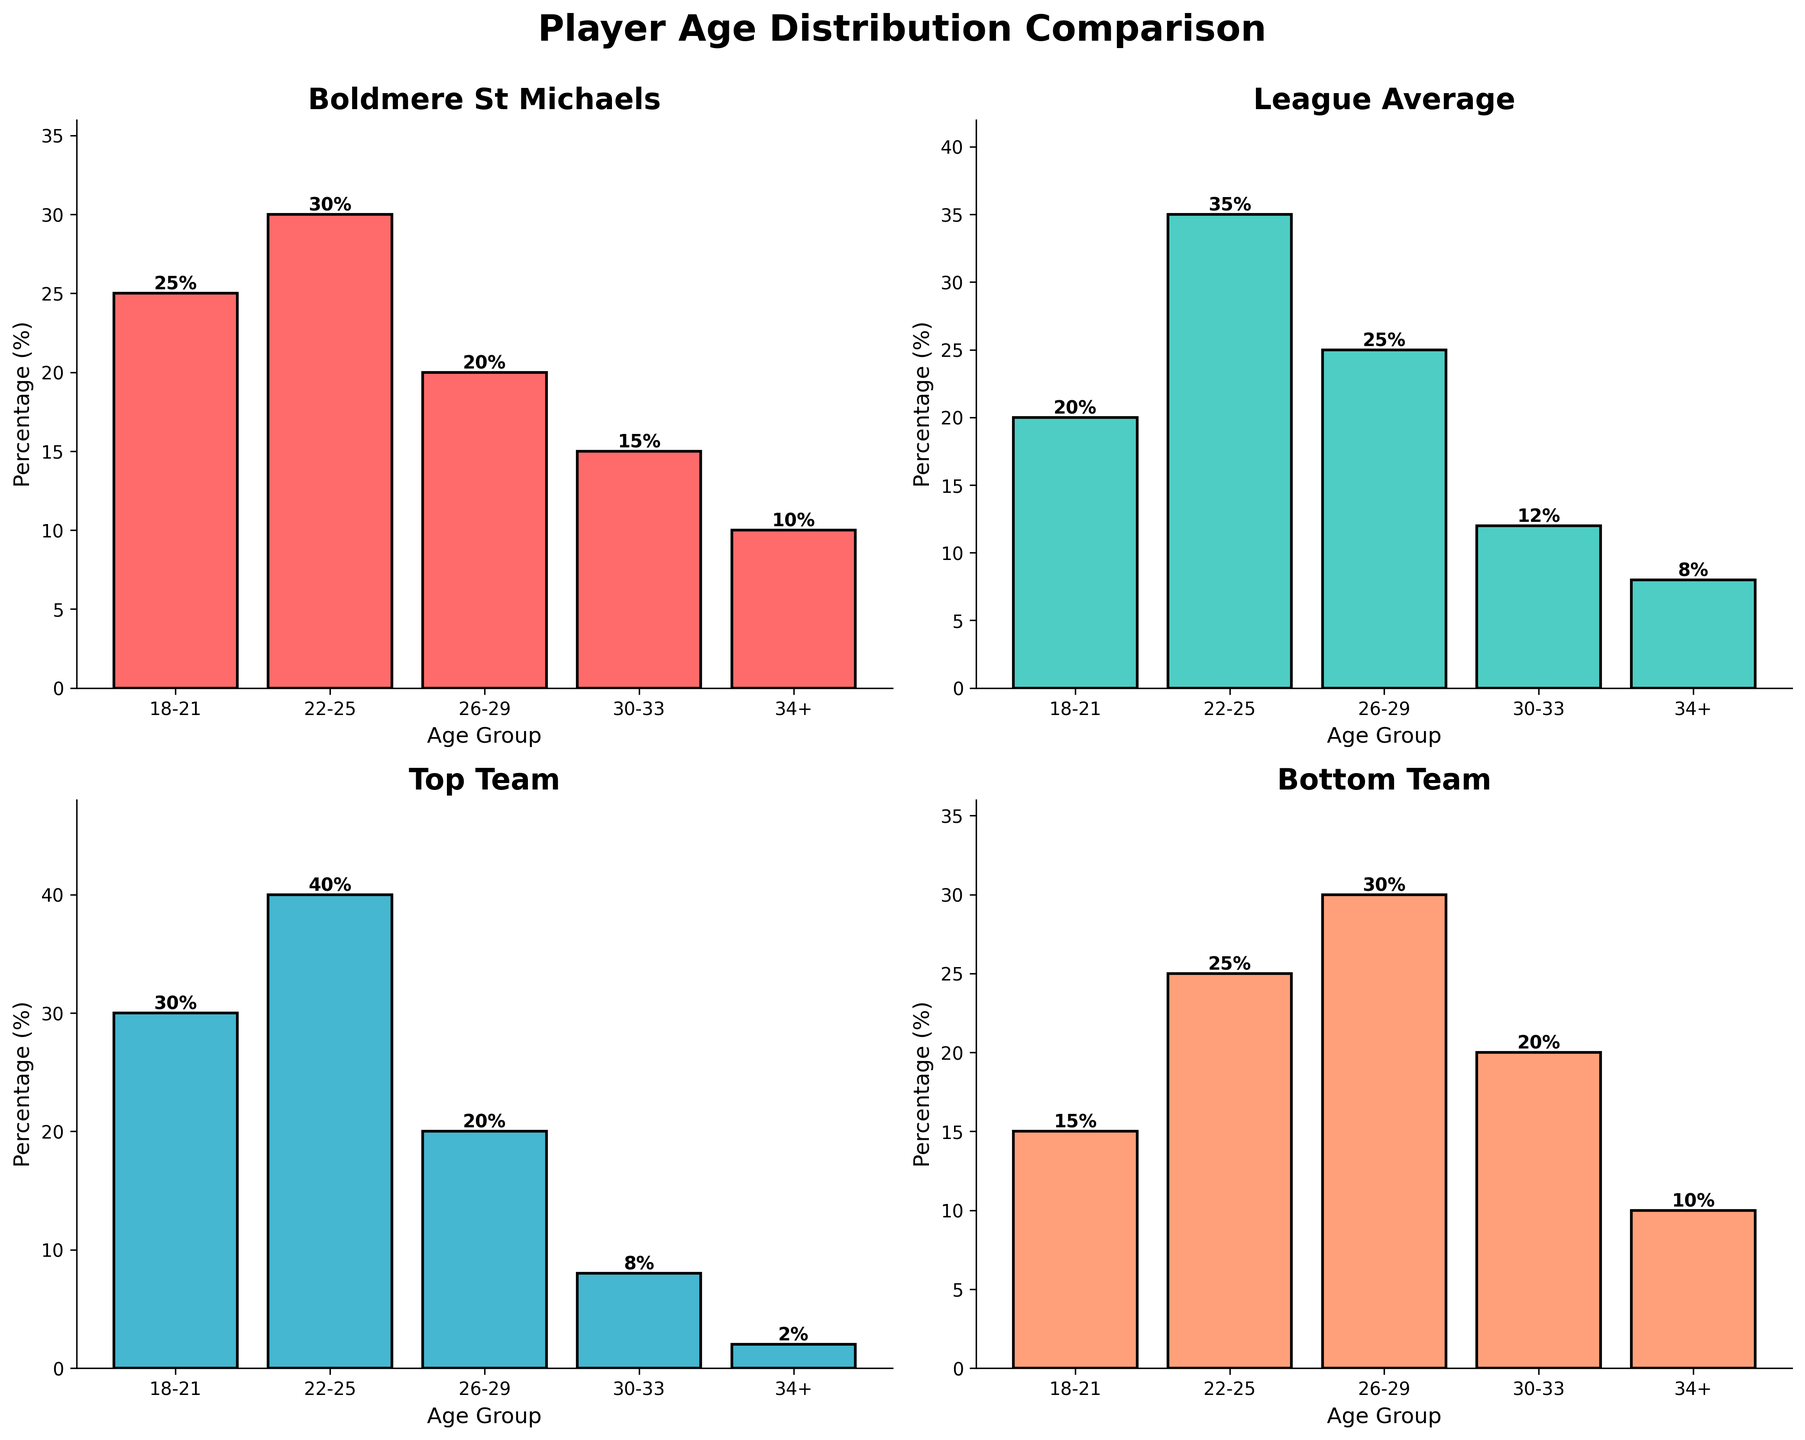Which team has the highest percentage of players aged 22-25? Comparing the bar heights in the 22-25 age group segment, Top Team has the highest bar at 40%.
Answer: Top Team How does the age distribution of Boldmere St. Michaels compare to the League Average in the 18-21 age group? Boldmere St. Michaels has 25% while the League Average has 20%. So, Boldmere St. Michaels has a higher percentage of players in this age group compared to the League Average.
Answer: Boldmere St. Michaels has a higher percentage Which age group has the smallest percentage of players in the Top Team? By scanning the charts, the 34+ age group has the smallest bar for Top Team, indicating 2%.
Answer: 34+ What's the difference in the percentage of players aged 30-33 between Boldmere St. Michaels and the League Average? Boldmere St. Michaels has 15% and the League Average has 12%. The difference is 15% - 12% = 3%.
Answer: 3% Which age group has the most significant difference in player percentage between the Bottom Team and Top Team? Calculate the differences for each age group: 18-21 (30-15)=15%, 22-25 (40-25)=15%, 26-29 (30-20)=10%, 30-33 (20-8)=12%, 34+ (10-2)=8%. The age group 18-21 and 22-25 both have the highest difference of 15%.
Answer: 18-21 and 22-25 How does Boldmere St. Michaels compare with the Bottom Team in the 34+ age group? Both Boldmere St. Michaels and the Bottom Team have 10% of their players in the 34+ age group.
Answer: They have the same percentage What is the trend in the percentage of players in Boldmere St. Michaels as age increases? The percentages are 25% (18-21), 30% (22-25), 20% (26-29), 15% (30-33), and 10% (34+). The percentage decreases as the age group increases.
Answer: Decreasing trend Which team has the flattest distribution of player ages? The League Average bars are the most uniform across all age groups compared to others.
Answer: League Average In the 22-25 age group, how much higher is the Top Team compared to the Bottom Team? The Top Team has 40% and the Bottom Team has 25%. The difference is 40% - 25% = 15%.
Answer: 15% What's the percentage of players aged 26-29 in Boldmere St. Michaels compared to the League Average? Boldmere St. Michaels has 20% while the League Average has 25% for the 26-29 age group.
Answer: Boldmere St. Michaels has a lower percentage 